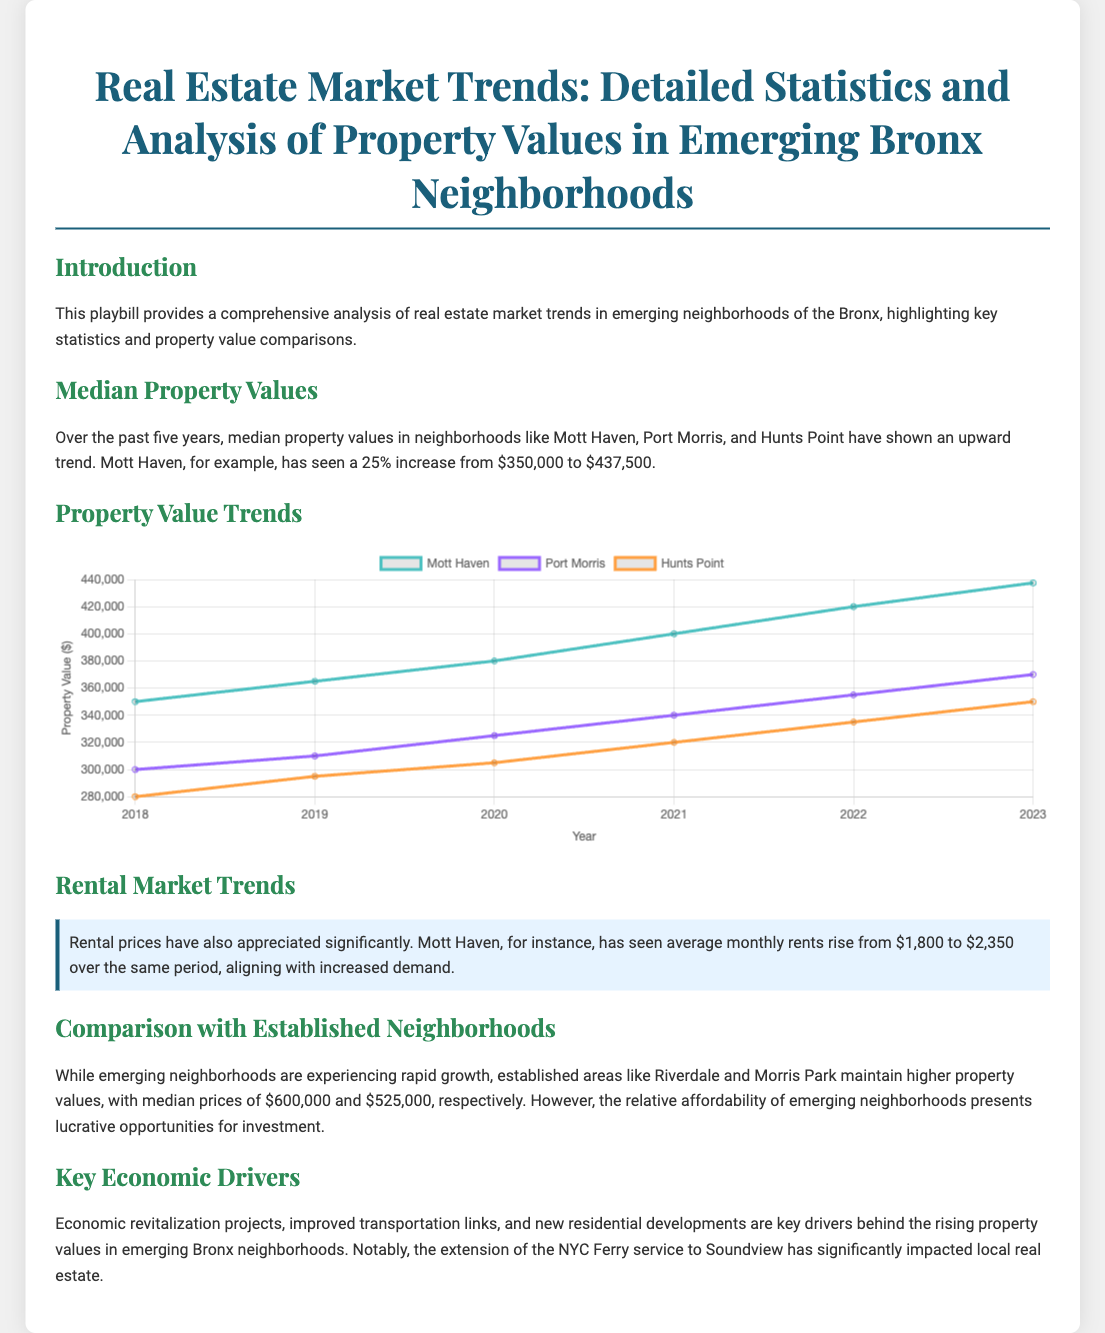What is the title of the document? The title of the document is found in the header, which states the focus of the analysis.
Answer: Real Estate Market Trends: Detailed Statistics and Analysis of Property Values in Emerging Bronx Neighborhoods What neighborhood saw a 25% increase in property value? The document specifies that Mott Haven is the neighborhood that experienced a significant increase in property value.
Answer: Mott Haven What was the median property value in Mott Haven in 2023? The document provides the updated median property value for Mott Haven at the end of the data range.
Answer: $437,500 How much did rental prices rise in Mott Haven? The document mentions the increase in average monthly rents in Mott Haven, highlighting the specific rise.
Answer: $550 What are the median property values for Riverdale and Morris Park? The document compares property values between emerging and established areas, specifically mentioning these two neighborhoods.
Answer: $600,000 and $525,000 What are the key economic drivers behind rising property values in the Bronx? The document lists economic factors contributing to the growth in property values, which are highlighted in a dedicated section.
Answer: Economic revitalization projects Which year shows the highest property value for Port Morris in the chart? According to the chart, the specific year that displays the peak value for Port Morris can be identified.
Answer: 2023 What is the average monthly rent in Mott Haven in 2018? The document indicates the starting figure for average monthly rents in Mott Haven for that year.
Answer: $1,800 Which neighborhood had the lowest property value in 2018? The document lists property values for multiple neighborhoods, allowing for a comparison to find the lowest value.
Answer: Hunts Point 